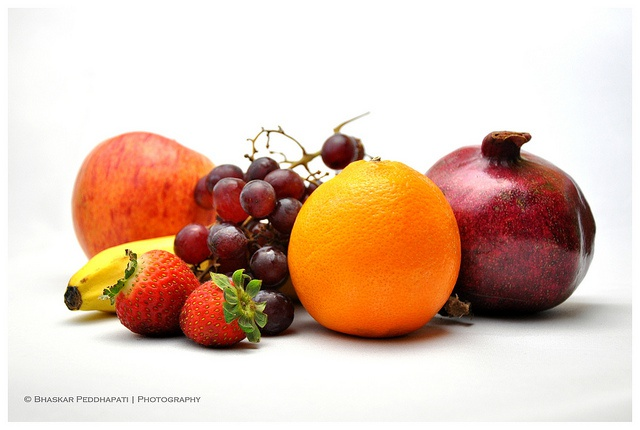Describe the objects in this image and their specific colors. I can see orange in white, red, orange, and gold tones, apple in white, red, and salmon tones, and banana in white, yellow, orange, gold, and olive tones in this image. 